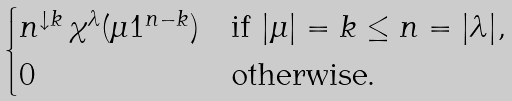Convert formula to latex. <formula><loc_0><loc_0><loc_500><loc_500>\begin{cases} n ^ { \downarrow k } \, \chi ^ { \lambda } ( \mu 1 ^ { n - k } ) & \text {if } | \mu | = k \leq n = | \lambda | , \\ 0 & \text {otherwise.} \end{cases}</formula> 